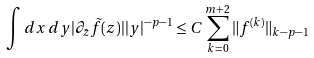Convert formula to latex. <formula><loc_0><loc_0><loc_500><loc_500>\int d x \, d y | \partial _ { \bar { z } } \tilde { f } ( z ) | | y | ^ { - p - 1 } \leq C \sum _ { k = 0 } ^ { m + 2 } \| f ^ { ( k ) } \| _ { k - p - 1 }</formula> 